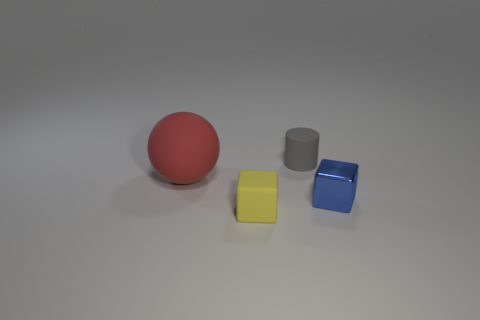Add 1 small gray rubber objects. How many objects exist? 5 Subtract all spheres. How many objects are left? 3 Subtract 1 yellow cubes. How many objects are left? 3 Subtract all blue metallic objects. Subtract all yellow objects. How many objects are left? 2 Add 4 large balls. How many large balls are left? 5 Add 1 metal objects. How many metal objects exist? 2 